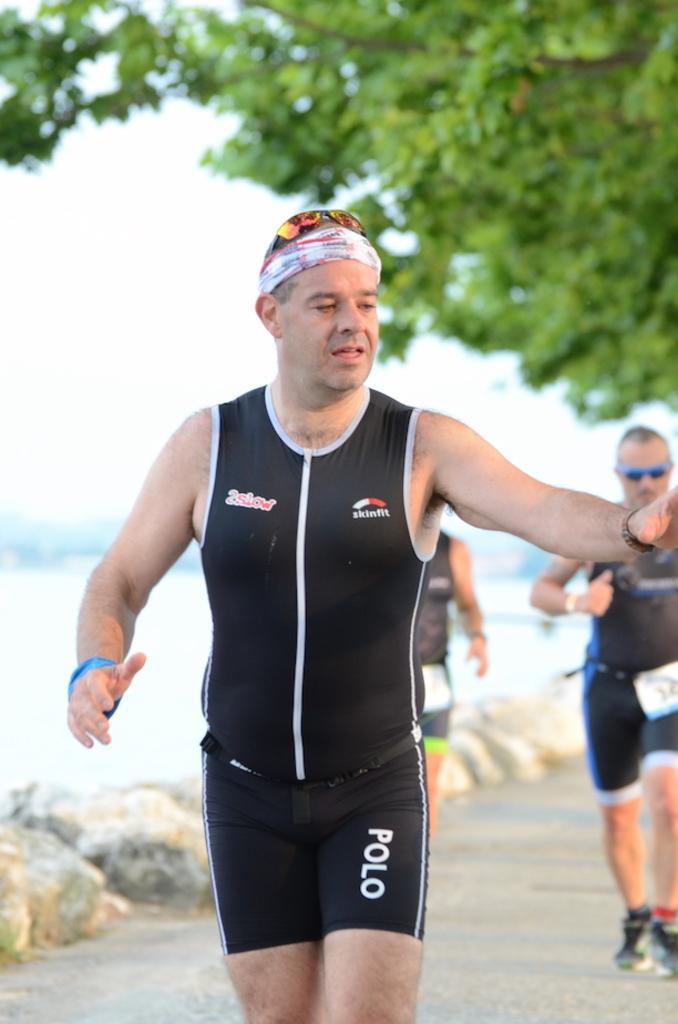In one or two sentences, can you explain what this image depicts? In this image we can see a person wearing black dress and glasses on his head is walking on the road. The background of the image is slightly blurred, where we can see a few more people walking on the road, we can see the trees and the sky. 